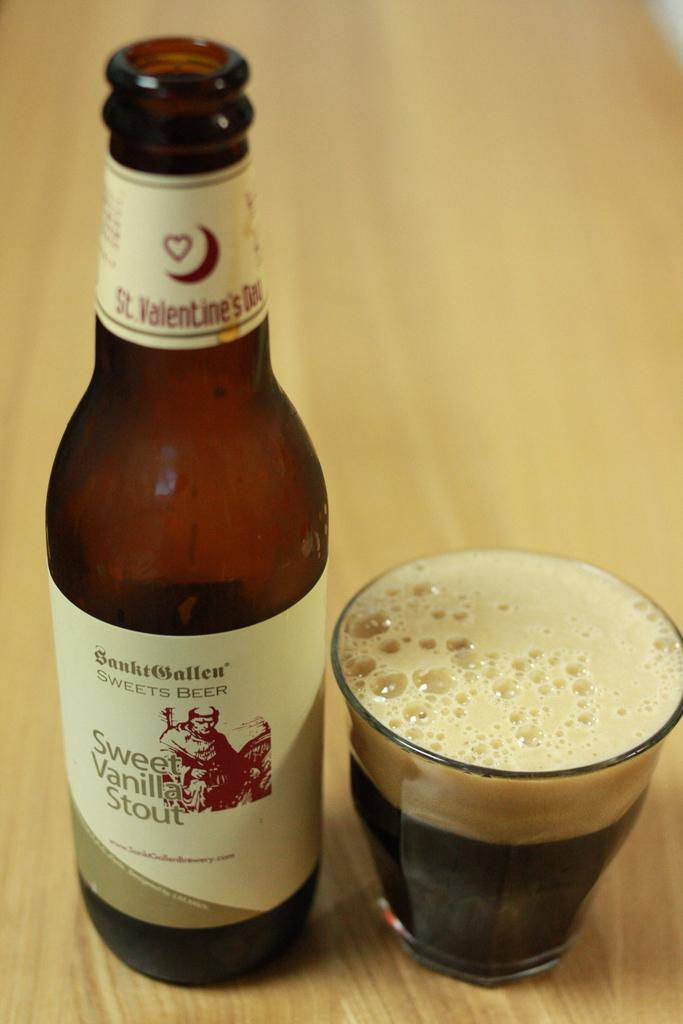<image>
Give a short and clear explanation of the subsequent image. A glass is next to a bottle of beer that says Sweet Vanilla Stout on the label. 